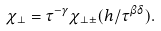Convert formula to latex. <formula><loc_0><loc_0><loc_500><loc_500>\chi _ { \perp } = \tau ^ { - \gamma } \chi _ { \perp \pm } ( h / \tau ^ { \beta \delta } ) .</formula> 